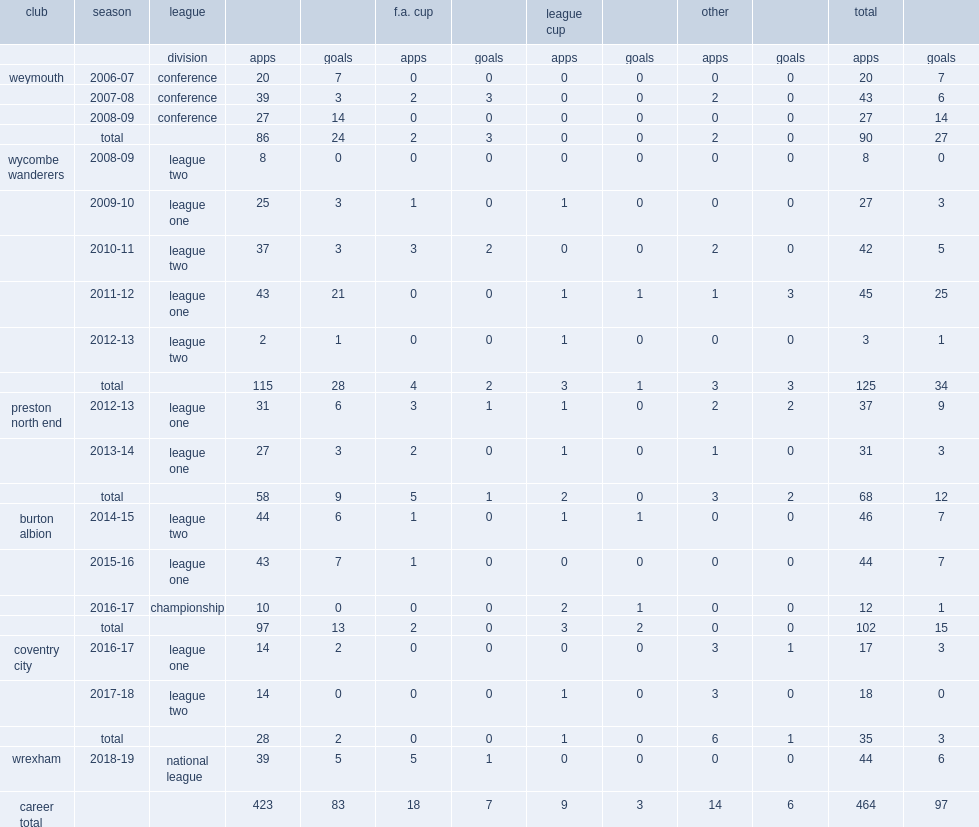Which league did beavon sign team wycombe wanderers until the end of the 2008-09 season? League two. 